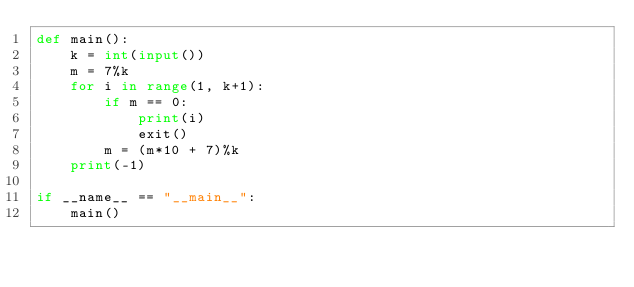<code> <loc_0><loc_0><loc_500><loc_500><_Python_>def main():
    k = int(input())
    m = 7%k
    for i in range(1, k+1):
        if m == 0:
            print(i)
            exit()
        m = (m*10 + 7)%k
    print(-1)

if __name__ == "__main__":
    main()</code> 